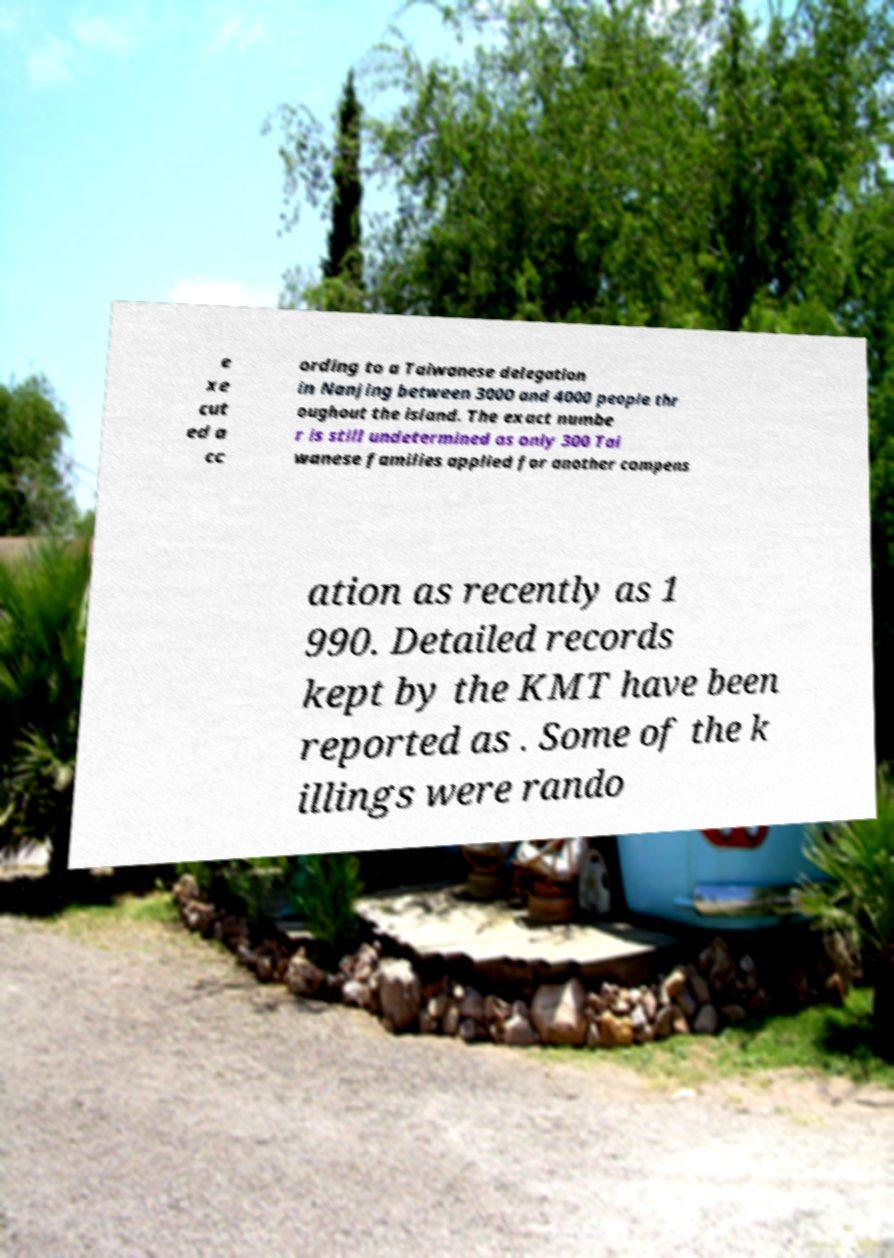Could you assist in decoding the text presented in this image and type it out clearly? e xe cut ed a cc ording to a Taiwanese delegation in Nanjing between 3000 and 4000 people thr oughout the island. The exact numbe r is still undetermined as only 300 Tai wanese families applied for another compens ation as recently as 1 990. Detailed records kept by the KMT have been reported as . Some of the k illings were rando 